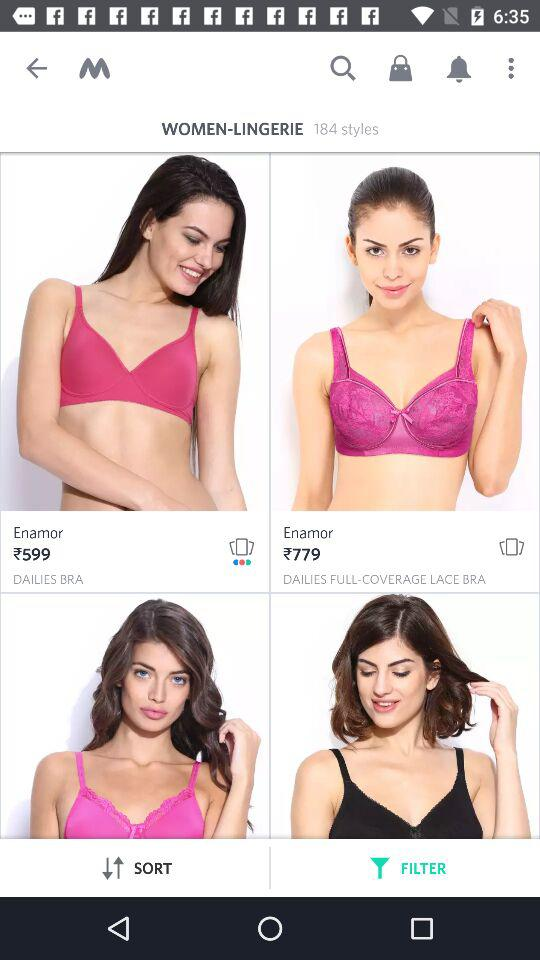What is the price of the Enamor dailies bra? The price of the dailies bra is 599 rupees. 